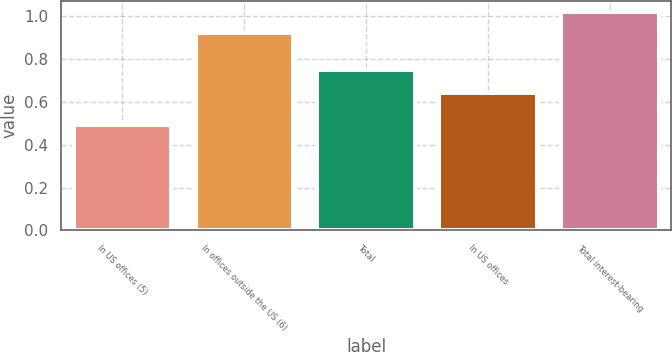<chart> <loc_0><loc_0><loc_500><loc_500><bar_chart><fcel>In US offices (5)<fcel>In offices outside the US (6)<fcel>Total<fcel>In US offices<fcel>Total interest-bearing<nl><fcel>0.49<fcel>0.92<fcel>0.75<fcel>0.64<fcel>1.02<nl></chart> 